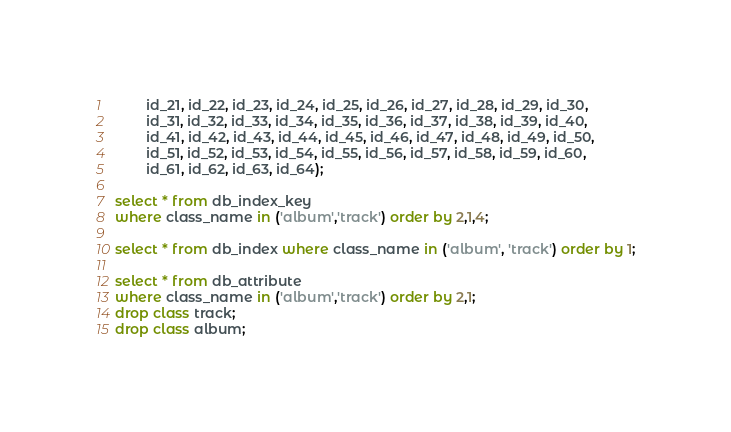<code> <loc_0><loc_0><loc_500><loc_500><_SQL_>		id_21, id_22, id_23, id_24, id_25, id_26, id_27, id_28, id_29, id_30, 
		id_31, id_32, id_33, id_34, id_35, id_36, id_37, id_38, id_39, id_40, 
		id_41, id_42, id_43, id_44, id_45, id_46, id_47, id_48, id_49, id_50, 
		id_51, id_52, id_53, id_54, id_55, id_56, id_57, id_58, id_59, id_60, 
		id_61, id_62, id_63, id_64);

select * from db_index_key
where class_name in ('album','track') order by 2,1,4;

select * from db_index where class_name in ('album', 'track') order by 1;

select * from db_attribute
where class_name in ('album','track') order by 2,1;
drop class track;
drop class album;</code> 